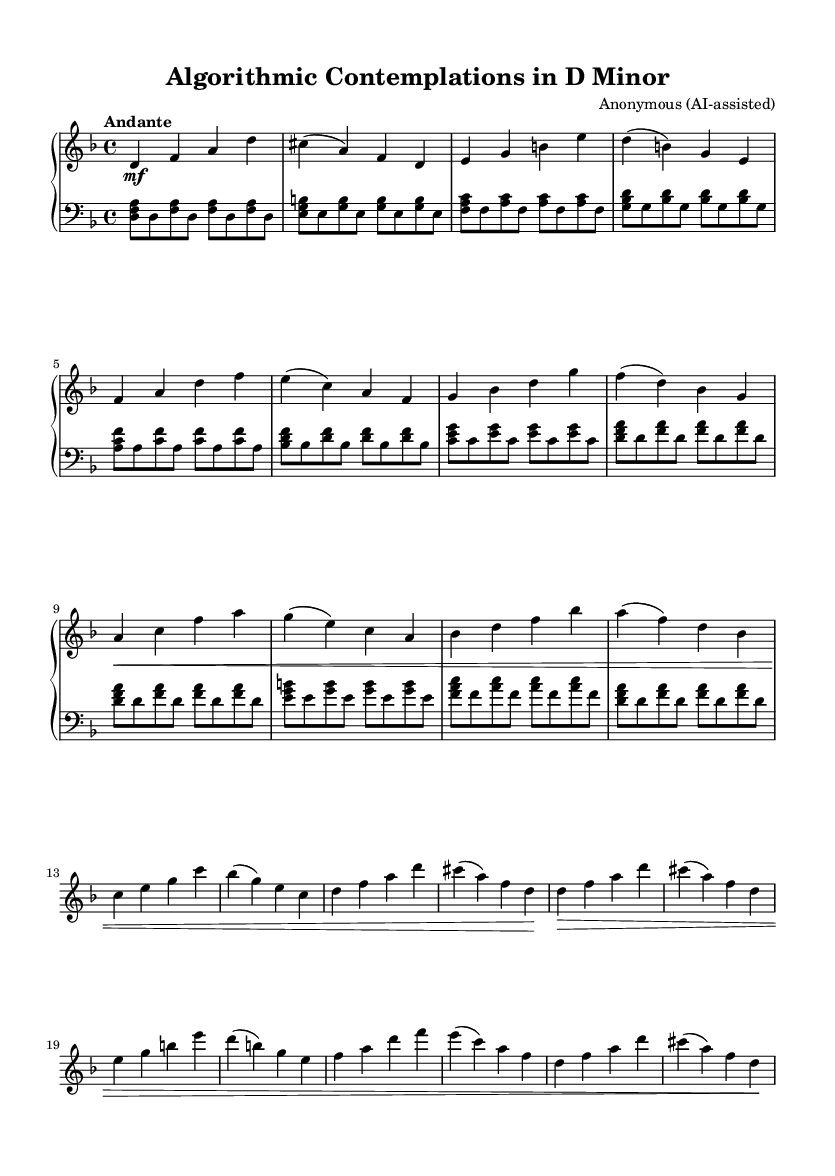what is the key signature of this music? The key signature indicates that the piece is in D minor, which contains one flat (B flat). This is confirmed by the key indication at the beginning of the staff, next to the time signature.
Answer: D minor what is the time signature of this music? The time signature is stated as 4/4, which means there are four beats in each measure and the quarter note gets one beat. This is indicated at the beginning of the score next to the key signature.
Answer: 4/4 what is the tempo marking for this piece? The tempo marking is "Andante" at a speed of quarter note equals 72 beats per minute. This is given at the top of the score, providing the performance speed guidance.
Answer: Andante, 72 how many sections are there in the piece? The piece consists of three main sections labeled A, B, and A'. The duplicating sections provide structure typical of Baroque pieces. Observations can be made from the labels marking changes in musical material.
Answer: Three which musical structure is commonly found in Baroque keyboard works as seen here? The piece exhibits a ternary structure (ABA). This is indicated by the separate sections A, B, and the return of A', often utilized in Baroque compositions for formality and contrast.
Answer: Ternary (ABA) what dynamics are indicated in the right-hand part of the music? The right hand is marked with dynamics such as "mf" (mezzo forte) and ">" (crescendo) at certain points. This indicates changes in volume and expression, which are marked next to the notes.
Answer: mf, > what are typical characteristics of Baroque keyboard works as reflected in this piece? This piece reflects characteristics such as ornamentation, expressiveness, and structured form. The repetitive harmonic and melodic motives along with the dynamic markings highlight the Baroque style.
Answer: Ornamentation and structured form 